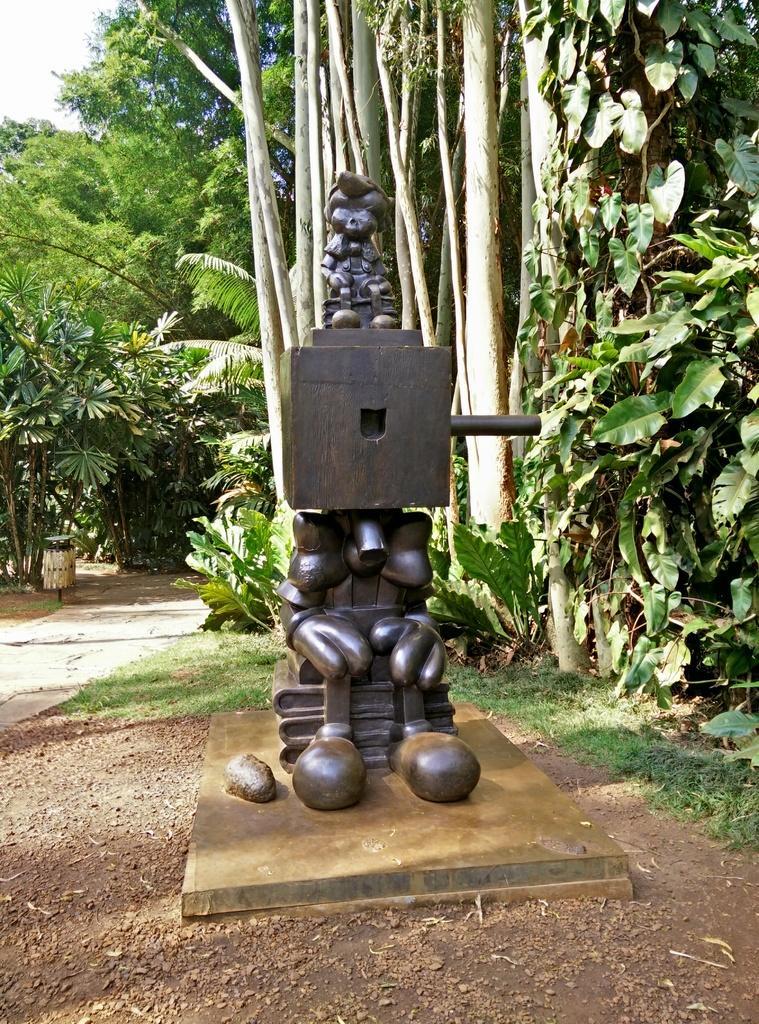Describe this image in one or two sentences. In the center of the image we can see a sculpture. In the background there are trees. At the bottom there is grass. 